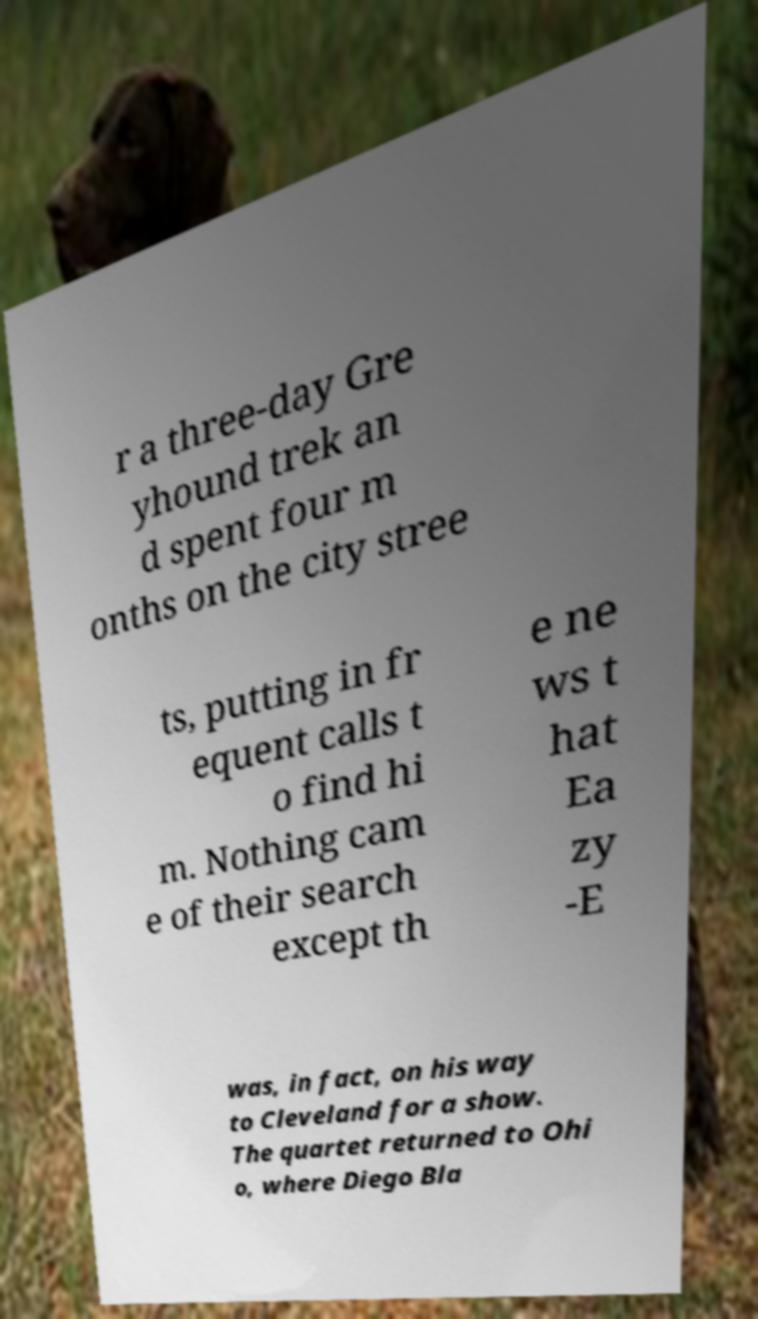I need the written content from this picture converted into text. Can you do that? r a three-day Gre yhound trek an d spent four m onths on the city stree ts, putting in fr equent calls t o find hi m. Nothing cam e of their search except th e ne ws t hat Ea zy -E was, in fact, on his way to Cleveland for a show. The quartet returned to Ohi o, where Diego Bla 